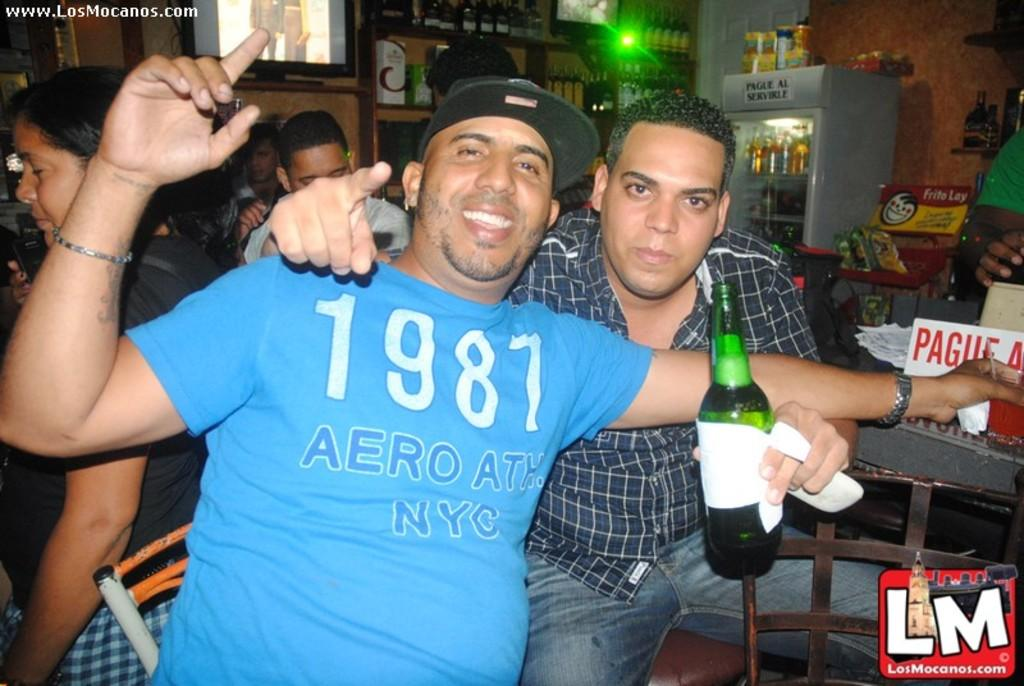What is the main subject of the image? The main subject of the image is a group of people. What are the people in the image doing? The people are sitting on a chair. Can you describe the action of the person in the front? The person in the front is holding a glass bottle in his hands. What type of dog can be seen sitting next to the person in the front? There is no dog present in the image; only a group of people sitting on a chair and holding a glass bottle are visible. 